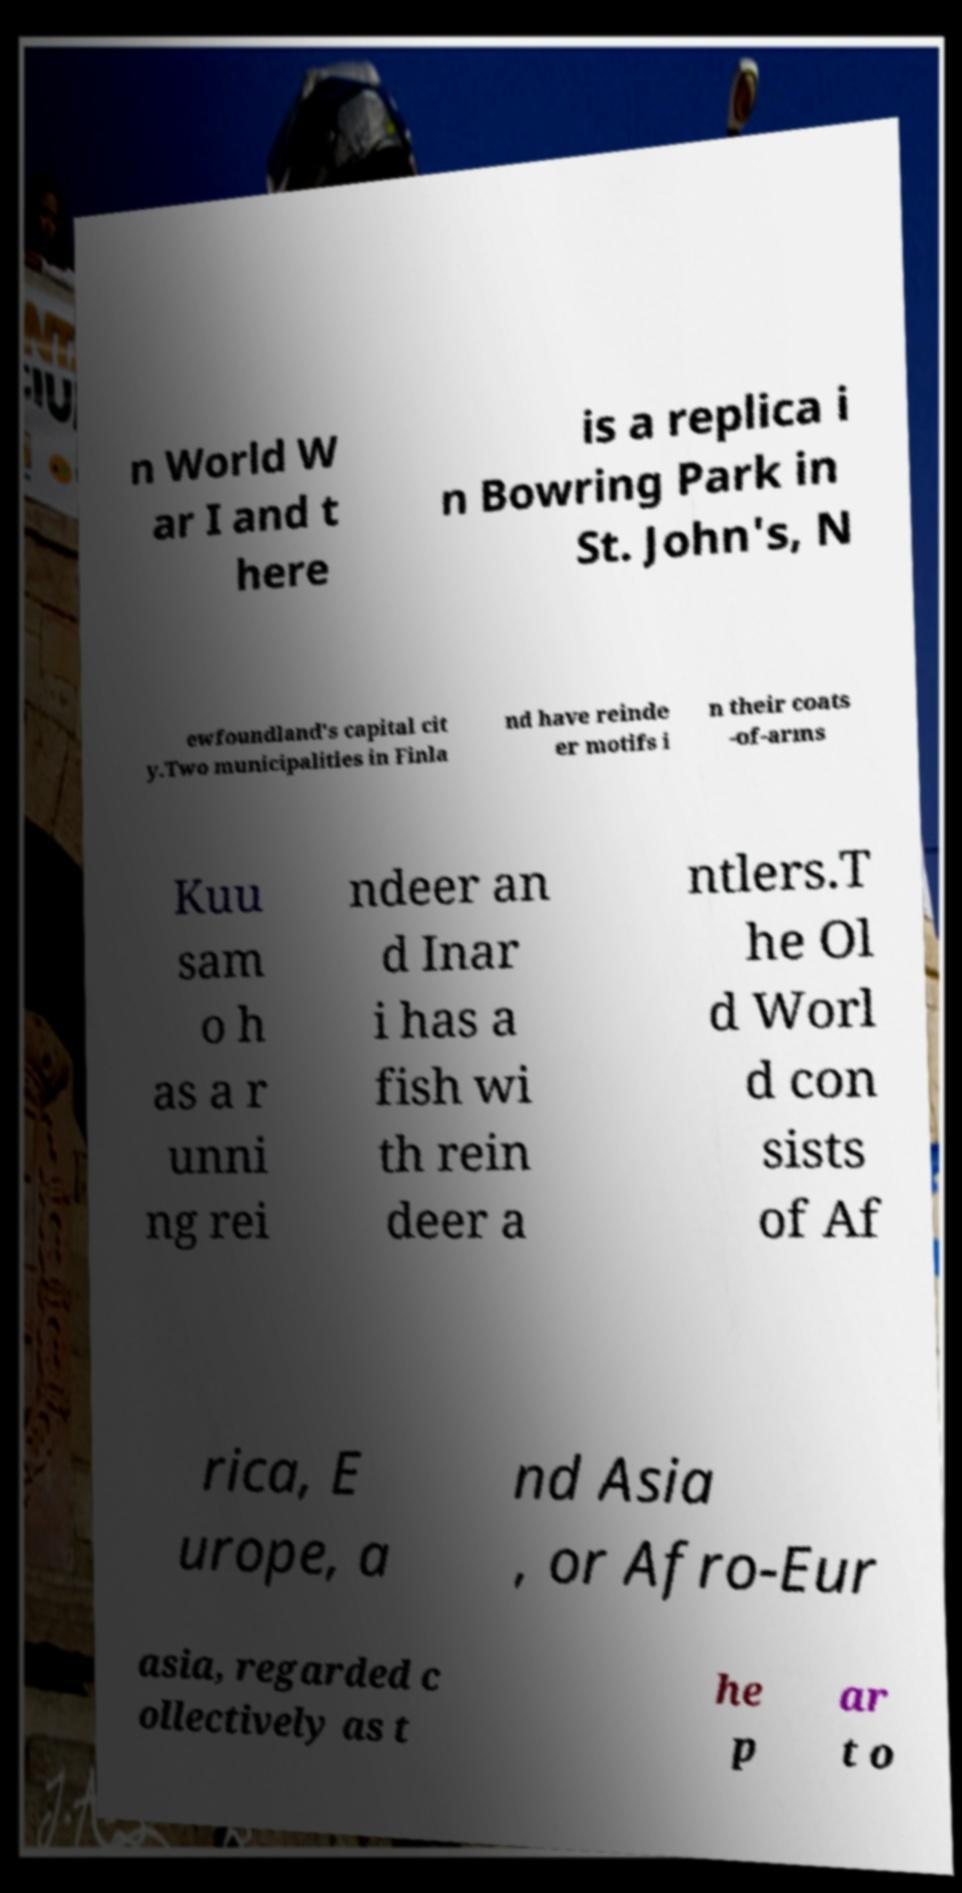Please identify and transcribe the text found in this image. n World W ar I and t here is a replica i n Bowring Park in St. John's, N ewfoundland's capital cit y.Two municipalities in Finla nd have reinde er motifs i n their coats -of-arms Kuu sam o h as a r unni ng rei ndeer an d Inar i has a fish wi th rein deer a ntlers.T he Ol d Worl d con sists of Af rica, E urope, a nd Asia , or Afro-Eur asia, regarded c ollectively as t he p ar t o 